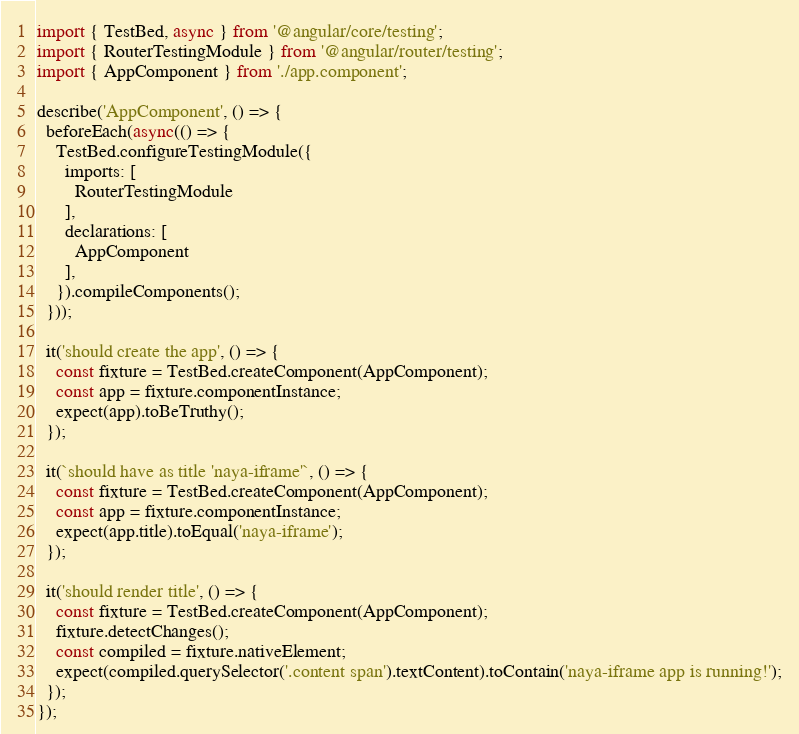<code> <loc_0><loc_0><loc_500><loc_500><_TypeScript_>import { TestBed, async } from '@angular/core/testing';
import { RouterTestingModule } from '@angular/router/testing';
import { AppComponent } from './app.component';

describe('AppComponent', () => {
  beforeEach(async(() => {
    TestBed.configureTestingModule({
      imports: [
        RouterTestingModule
      ],
      declarations: [
        AppComponent
      ],
    }).compileComponents();
  }));

  it('should create the app', () => {
    const fixture = TestBed.createComponent(AppComponent);
    const app = fixture.componentInstance;
    expect(app).toBeTruthy();
  });

  it(`should have as title 'naya-iframe'`, () => {
    const fixture = TestBed.createComponent(AppComponent);
    const app = fixture.componentInstance;
    expect(app.title).toEqual('naya-iframe');
  });

  it('should render title', () => {
    const fixture = TestBed.createComponent(AppComponent);
    fixture.detectChanges();
    const compiled = fixture.nativeElement;
    expect(compiled.querySelector('.content span').textContent).toContain('naya-iframe app is running!');
  });
});
</code> 